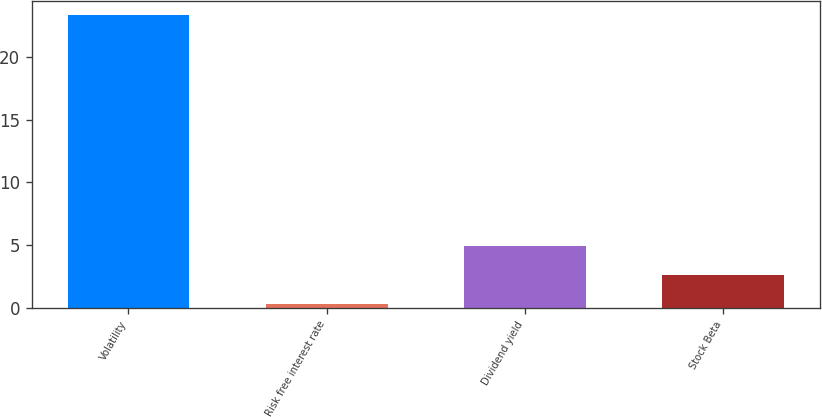Convert chart. <chart><loc_0><loc_0><loc_500><loc_500><bar_chart><fcel>Volatility<fcel>Risk free interest rate<fcel>Dividend yield<fcel>Stock Beta<nl><fcel>23.3<fcel>0.33<fcel>4.93<fcel>2.63<nl></chart> 